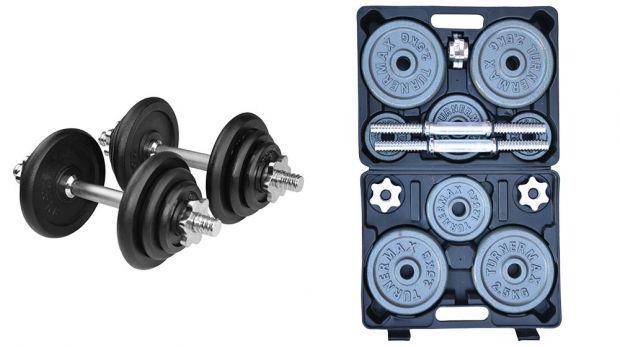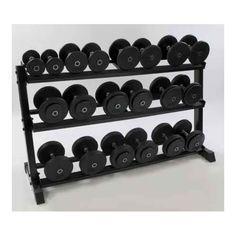The first image is the image on the left, the second image is the image on the right. For the images displayed, is the sentence "In one of the images there is a large rack full of various sized barbells." factually correct? Answer yes or no. Yes. The first image is the image on the left, the second image is the image on the right. For the images shown, is this caption "The rack in the image on the right holds more than a dozen weights." true? Answer yes or no. Yes. 